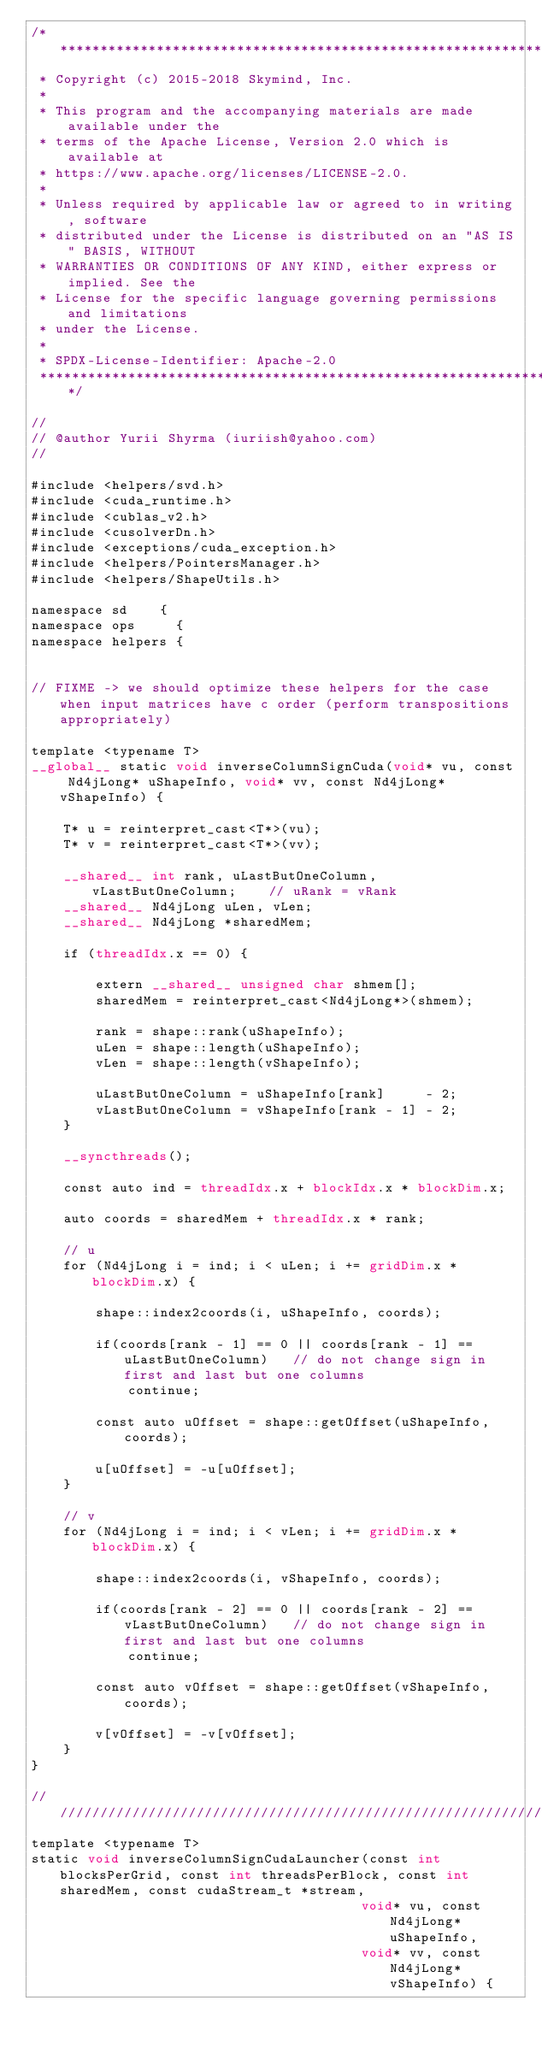<code> <loc_0><loc_0><loc_500><loc_500><_Cuda_>/*******************************************************************************
 * Copyright (c) 2015-2018 Skymind, Inc.
 *
 * This program and the accompanying materials are made available under the
 * terms of the Apache License, Version 2.0 which is available at
 * https://www.apache.org/licenses/LICENSE-2.0.
 *
 * Unless required by applicable law or agreed to in writing, software
 * distributed under the License is distributed on an "AS IS" BASIS, WITHOUT
 * WARRANTIES OR CONDITIONS OF ANY KIND, either express or implied. See the
 * License for the specific language governing permissions and limitations
 * under the License.
 *
 * SPDX-License-Identifier: Apache-2.0
 ******************************************************************************/

//
// @author Yurii Shyrma (iuriish@yahoo.com)
//

#include <helpers/svd.h>
#include <cuda_runtime.h>
#include <cublas_v2.h>
#include <cusolverDn.h>
#include <exceptions/cuda_exception.h>
#include <helpers/PointersManager.h>
#include <helpers/ShapeUtils.h>

namespace sd    {
namespace ops     {
namespace helpers {


// FIXME -> we should optimize these helpers for the case when input matrices have c order (perform transpositions appropriately)

template <typename T>
__global__ static void inverseColumnSignCuda(void* vu, const Nd4jLong* uShapeInfo, void* vv, const Nd4jLong* vShapeInfo) {

    T* u = reinterpret_cast<T*>(vu);
    T* v = reinterpret_cast<T*>(vv);

    __shared__ int rank, uLastButOneColumn, vLastButOneColumn;    // uRank = vRank
    __shared__ Nd4jLong uLen, vLen;
    __shared__ Nd4jLong *sharedMem;

    if (threadIdx.x == 0) {

        extern __shared__ unsigned char shmem[];
        sharedMem = reinterpret_cast<Nd4jLong*>(shmem);

        rank = shape::rank(uShapeInfo);
        uLen = shape::length(uShapeInfo);
        vLen = shape::length(vShapeInfo);

        uLastButOneColumn = uShapeInfo[rank]     - 2;
        vLastButOneColumn = vShapeInfo[rank - 1] - 2;
    }

    __syncthreads();

    const auto ind = threadIdx.x + blockIdx.x * blockDim.x;

    auto coords = sharedMem + threadIdx.x * rank;

    // u
    for (Nd4jLong i = ind; i < uLen; i += gridDim.x * blockDim.x) {

        shape::index2coords(i, uShapeInfo, coords);

        if(coords[rank - 1] == 0 || coords[rank - 1] == uLastButOneColumn)   // do not change sign in first and last but one columns
            continue;

        const auto uOffset = shape::getOffset(uShapeInfo, coords);

        u[uOffset] = -u[uOffset];
    }

    // v
    for (Nd4jLong i = ind; i < vLen; i += gridDim.x * blockDim.x) {

        shape::index2coords(i, vShapeInfo, coords);

        if(coords[rank - 2] == 0 || coords[rank - 2] == vLastButOneColumn)   // do not change sign in first and last but one columns
            continue;

        const auto vOffset = shape::getOffset(vShapeInfo, coords);

        v[vOffset] = -v[vOffset];
    }
}

//////////////////////////////////////////////////////////////////////////
template <typename T>
static void inverseColumnSignCudaLauncher(const int blocksPerGrid, const int threadsPerBlock, const int sharedMem, const cudaStream_t *stream,
                                         void* vu, const Nd4jLong* uShapeInfo,
                                         void* vv, const Nd4jLong* vShapeInfo) {
</code> 